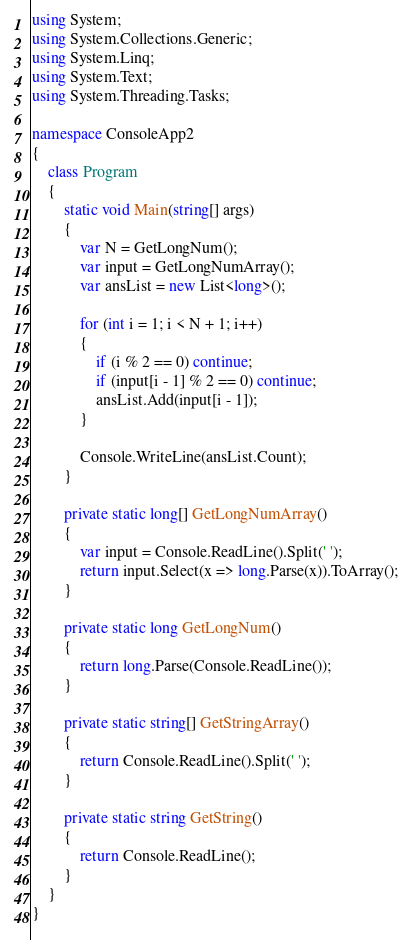Convert code to text. <code><loc_0><loc_0><loc_500><loc_500><_C#_>using System;
using System.Collections.Generic;
using System.Linq;
using System.Text;
using System.Threading.Tasks;

namespace ConsoleApp2
{
    class Program
    {
        static void Main(string[] args)
        {
            var N = GetLongNum();
            var input = GetLongNumArray();
            var ansList = new List<long>();

            for (int i = 1; i < N + 1; i++)
            {
                if (i % 2 == 0) continue;
                if (input[i - 1] % 2 == 0) continue;
                ansList.Add(input[i - 1]);
            }

            Console.WriteLine(ansList.Count);
        }

        private static long[] GetLongNumArray()
        {
            var input = Console.ReadLine().Split(' ');
            return input.Select(x => long.Parse(x)).ToArray();
        }

        private static long GetLongNum()
        {
            return long.Parse(Console.ReadLine());
        }

        private static string[] GetStringArray()
        {
            return Console.ReadLine().Split(' ');
        }

        private static string GetString()
        {
            return Console.ReadLine();
        }
    }
}
</code> 